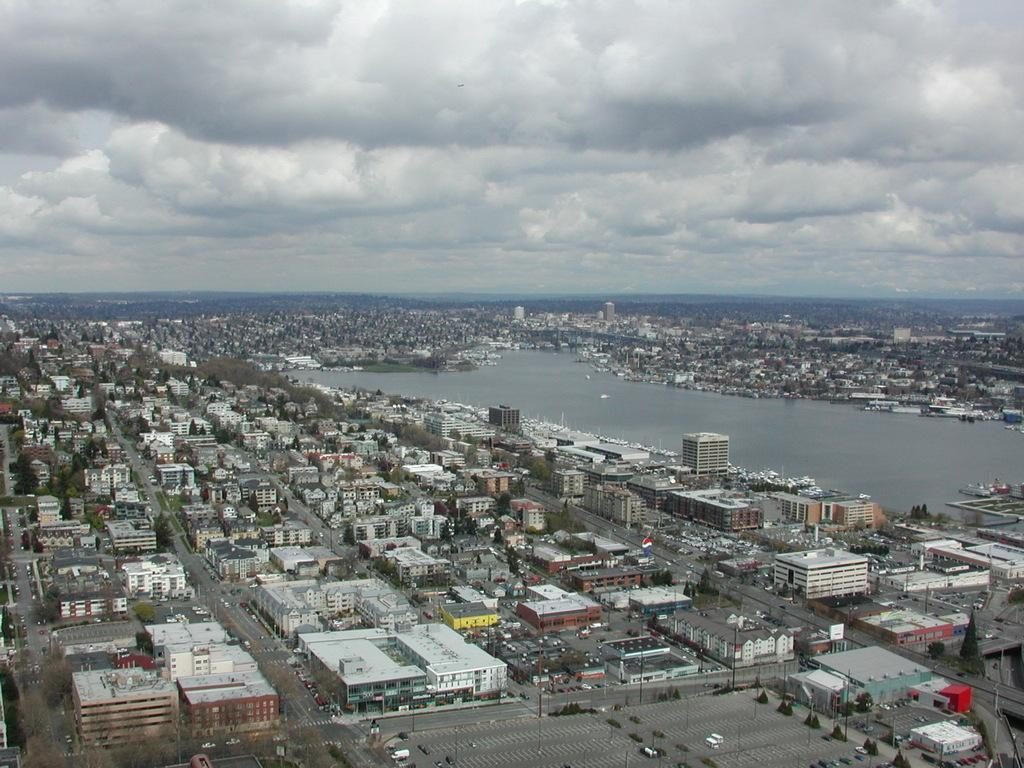What type of structures can be seen in the image? There are buildings visible in the image. What can be used for transportation in the image? Roads are present in the image for transportation. What type of vegetation is visible in the image? Trees are visible in the image. What natural element is visible in the image? There is water visible in the image. What is visible above the image? The sky is visible in the image. What can be seen in the sky in the image? Clouds are present in the sky. What type of curtain is hanging on the side of the building in the image? There is no curtain present on the side of any building in the image. 